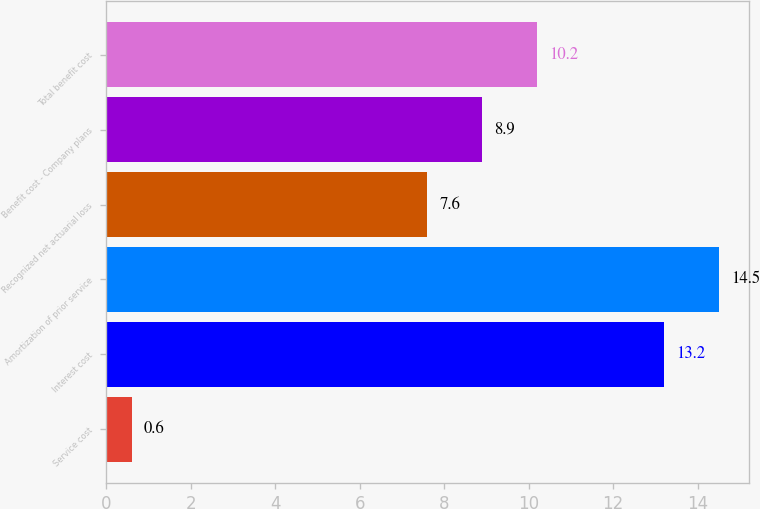Convert chart to OTSL. <chart><loc_0><loc_0><loc_500><loc_500><bar_chart><fcel>Service cost<fcel>Interest cost<fcel>Amortization of prior service<fcel>Recognized net actuarial loss<fcel>Benefit cost - Company plans<fcel>Total benefit cost<nl><fcel>0.6<fcel>13.2<fcel>14.5<fcel>7.6<fcel>8.9<fcel>10.2<nl></chart> 